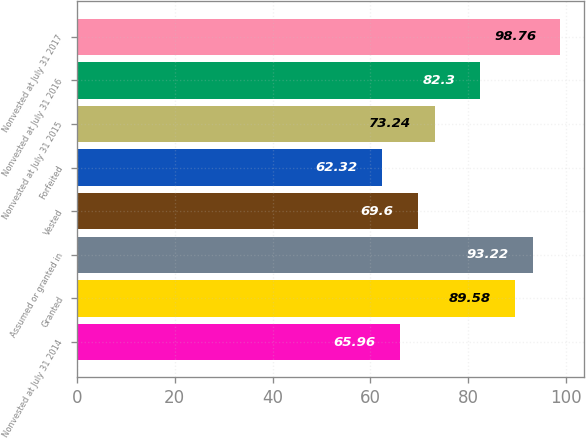Convert chart to OTSL. <chart><loc_0><loc_0><loc_500><loc_500><bar_chart><fcel>Nonvested at July 31 2014<fcel>Granted<fcel>Assumed or granted in<fcel>Vested<fcel>Forfeited<fcel>Nonvested at July 31 2015<fcel>Nonvested at July 31 2016<fcel>Nonvested at July 31 2017<nl><fcel>65.96<fcel>89.58<fcel>93.22<fcel>69.6<fcel>62.32<fcel>73.24<fcel>82.3<fcel>98.76<nl></chart> 